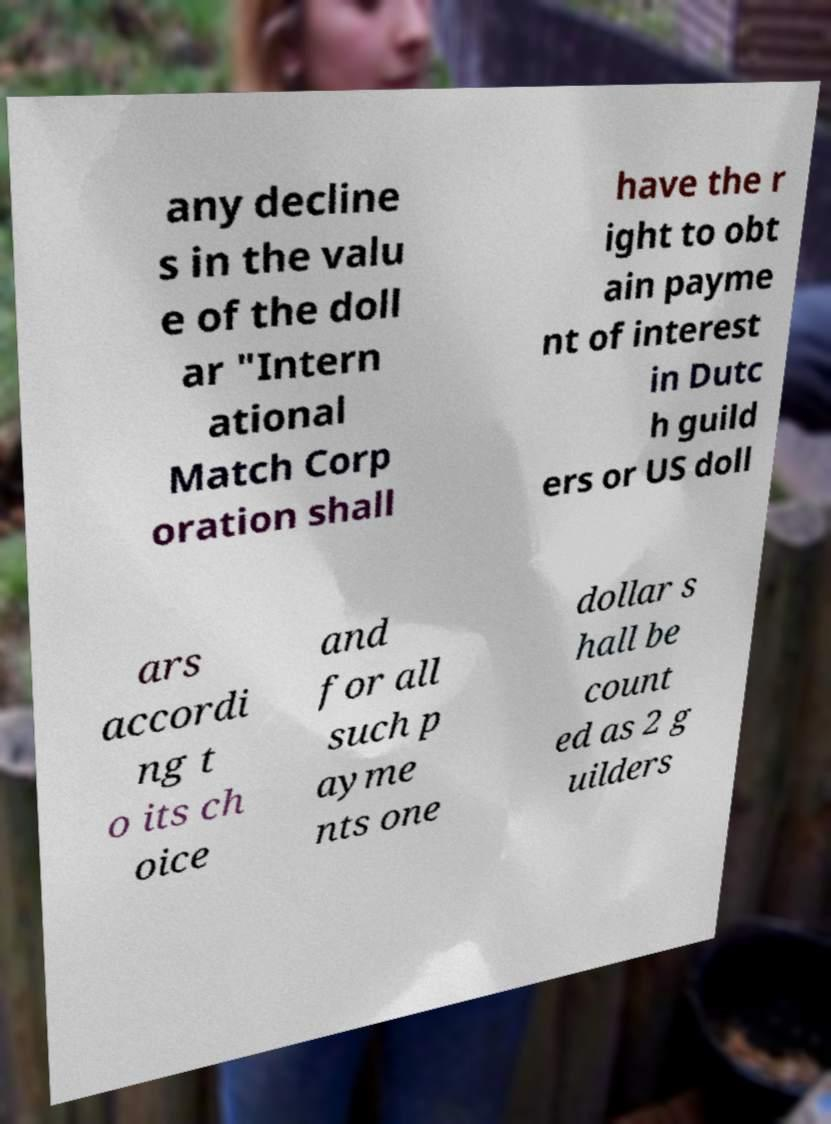Could you extract and type out the text from this image? any decline s in the valu e of the doll ar "Intern ational Match Corp oration shall have the r ight to obt ain payme nt of interest in Dutc h guild ers or US doll ars accordi ng t o its ch oice and for all such p ayme nts one dollar s hall be count ed as 2 g uilders 